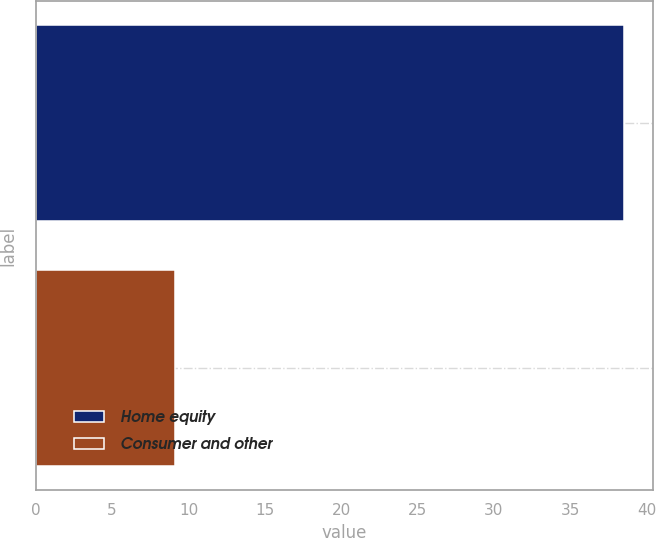<chart> <loc_0><loc_0><loc_500><loc_500><bar_chart><fcel>Home equity<fcel>Consumer and other<nl><fcel>38.5<fcel>9.1<nl></chart> 